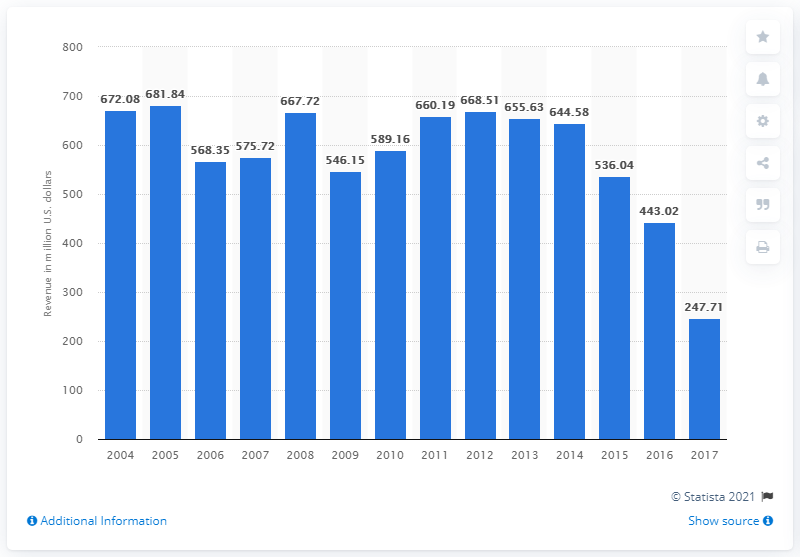Draw attention to some important aspects in this diagram. In 2017, the total revenue of Air Wisconsin Airlines was 247.71 million dollars. 